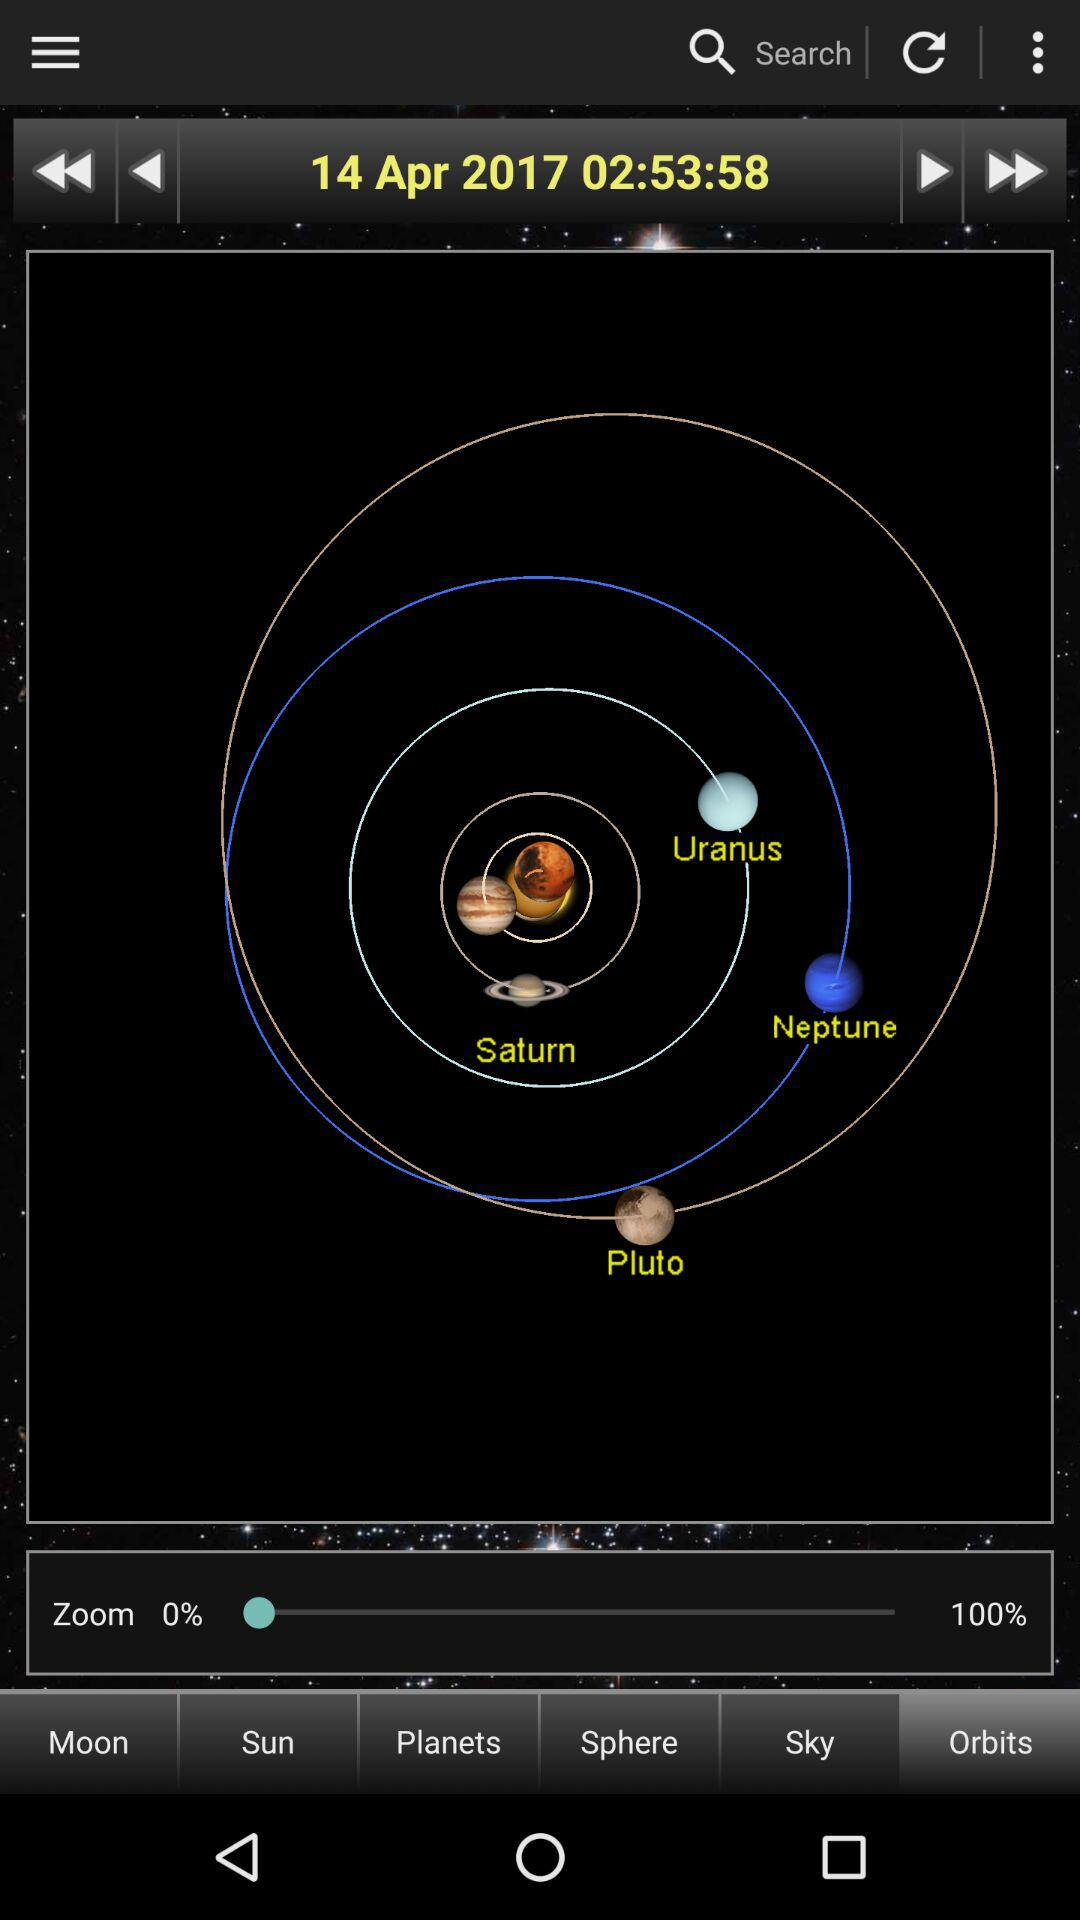What time is shown in the application? The time is 02:53:58. 